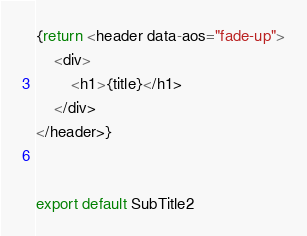<code> <loc_0><loc_0><loc_500><loc_500><_TypeScript_>{return <header data-aos="fade-up">
    <div>
        <h1>{title}</h1>
    </div>
</header>}


export default SubTitle2</code> 